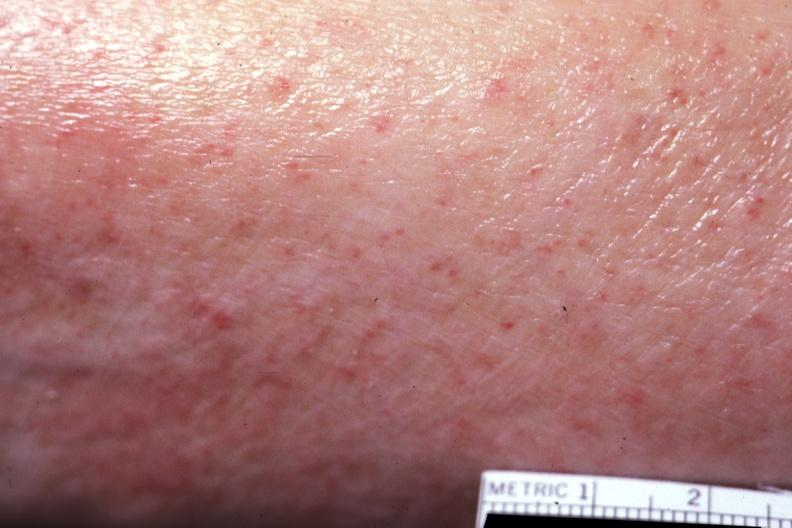s petechial hemorrhages present?
Answer the question using a single word or phrase. Yes 